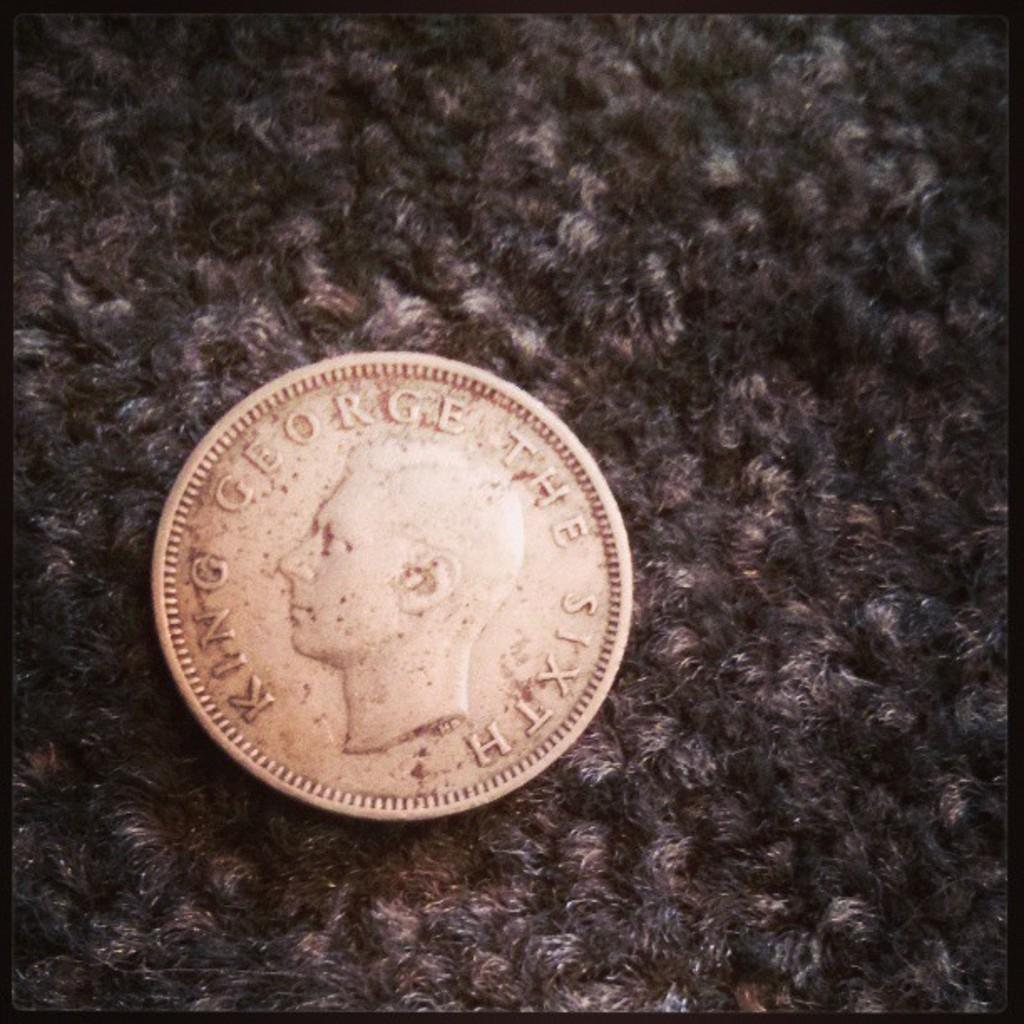What object is the main focus of the image? The main focus of the image is a coin. What is depicted on the coin? The coin has the print of a king on it. How many times did your grandfather flip the coin in the image? There is no mention of a grandfather or any coin flipping in the image, so we cannot answer this question. 